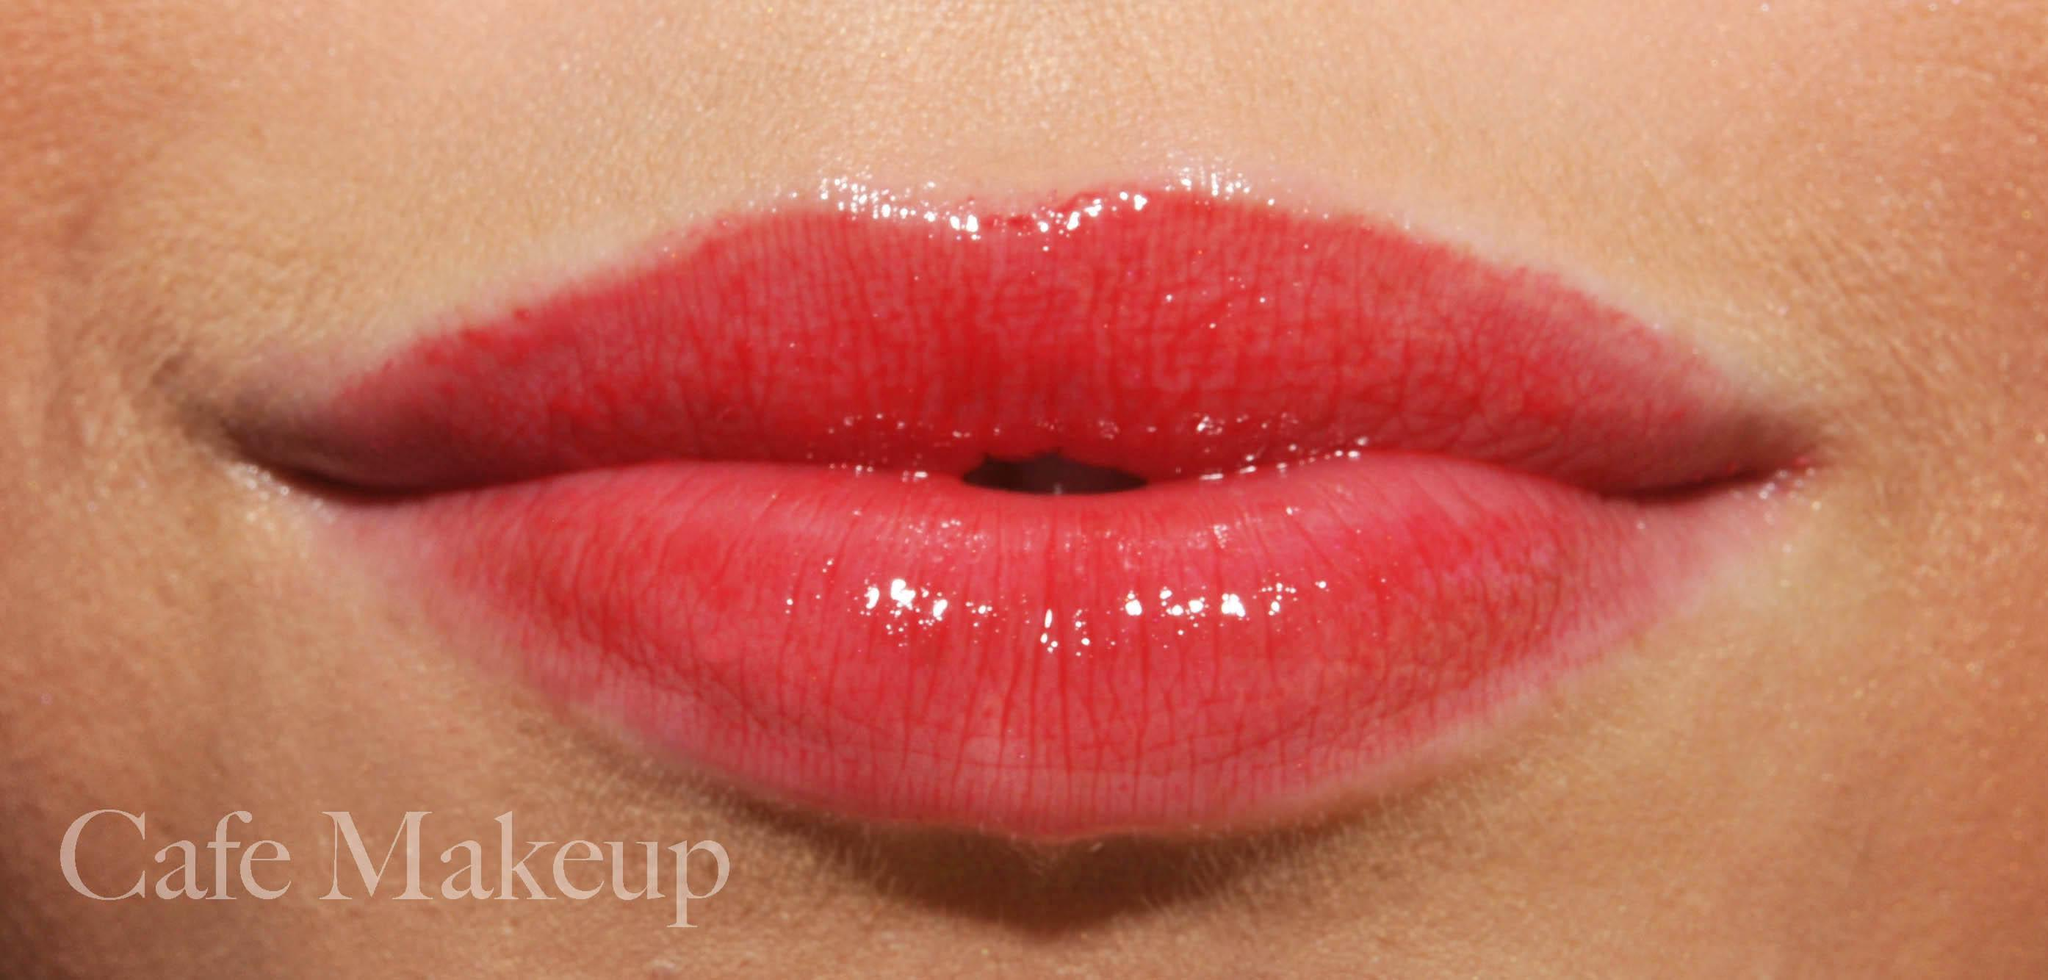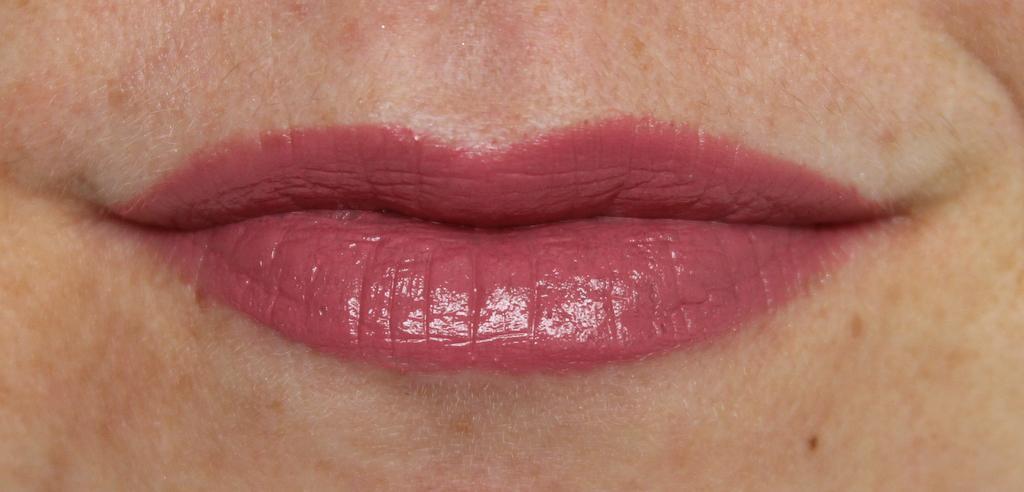The first image is the image on the left, the second image is the image on the right. Analyze the images presented: Is the assertion "The lips on the right have a more lavender tint than the lips on the left, which are more coral colored." valid? Answer yes or no. Yes. 